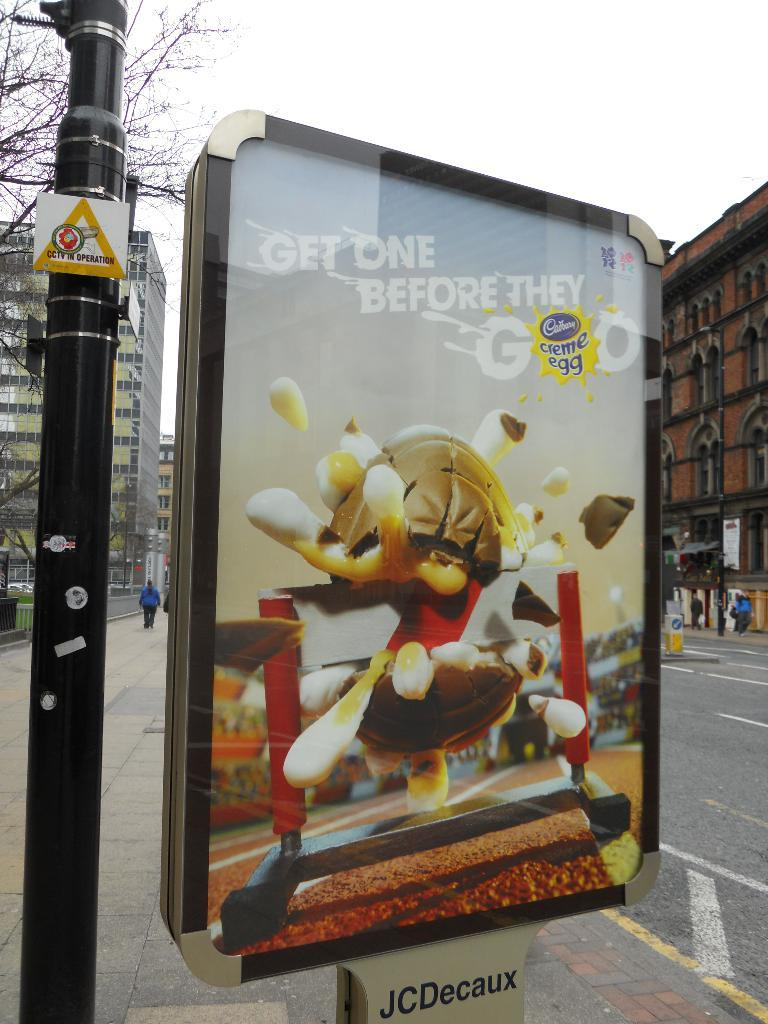Provide a one-sentence caption for the provided image. An outdoor advertisement for Cadberry creme eggs with depiction of a creme egg exploding through a runners hurdle. 